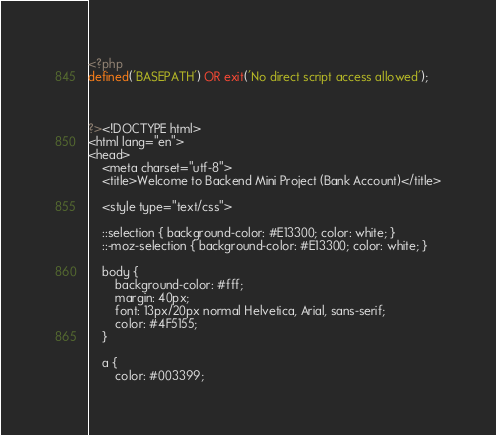Convert code to text. <code><loc_0><loc_0><loc_500><loc_500><_PHP_><?php
defined('BASEPATH') OR exit('No direct script access allowed');

       

?><!DOCTYPE html>
<html lang="en">
<head>
	<meta charset="utf-8">
	<title>Welcome to Backend Mini Project (Bank Account)</title>

	<style type="text/css">

	::selection { background-color: #E13300; color: white; }
	::-moz-selection { background-color: #E13300; color: white; }

	body {
		background-color: #fff;
		margin: 40px;
		font: 13px/20px normal Helvetica, Arial, sans-serif;
		color: #4F5155;
	}

	a {
		color: #003399;</code> 